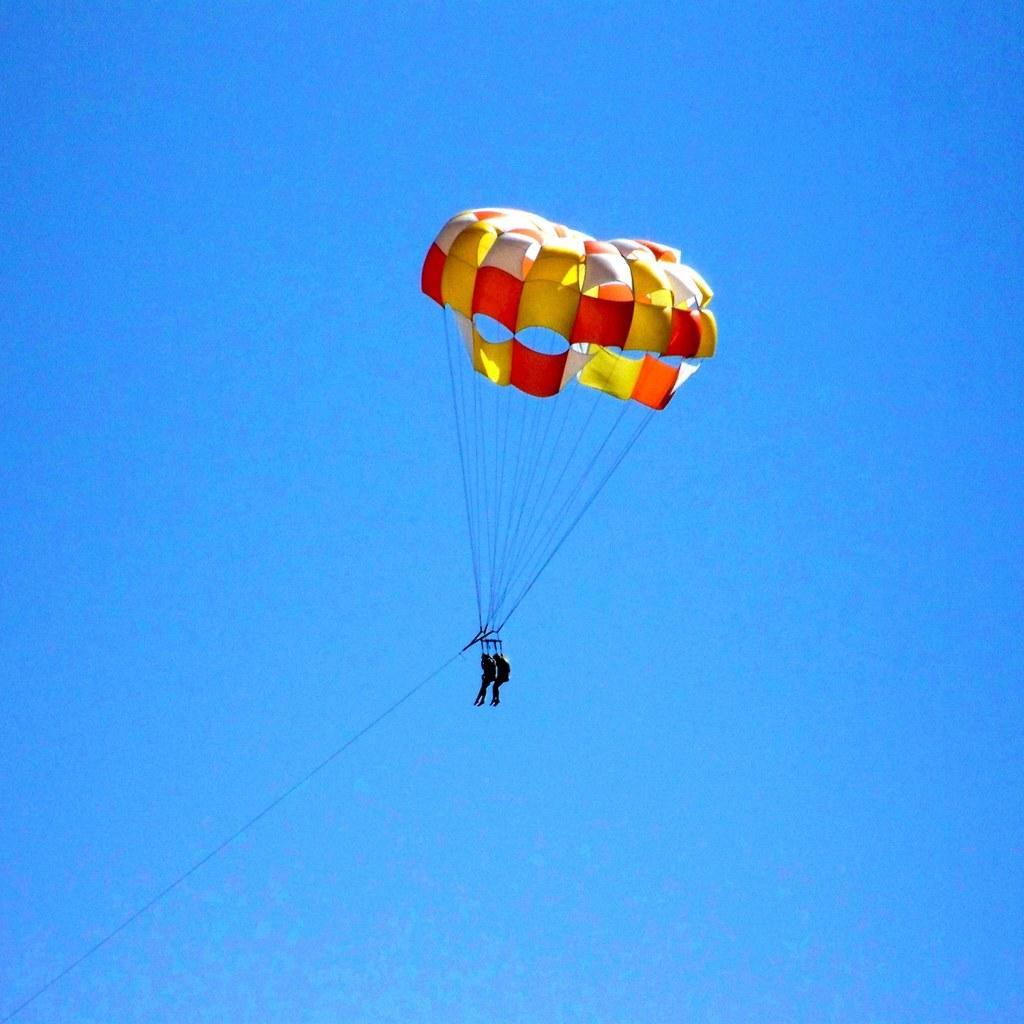In one or two sentences, can you explain what this image depicts? In this image two persons are paragliding. This is the parachute. The sky is clear. 